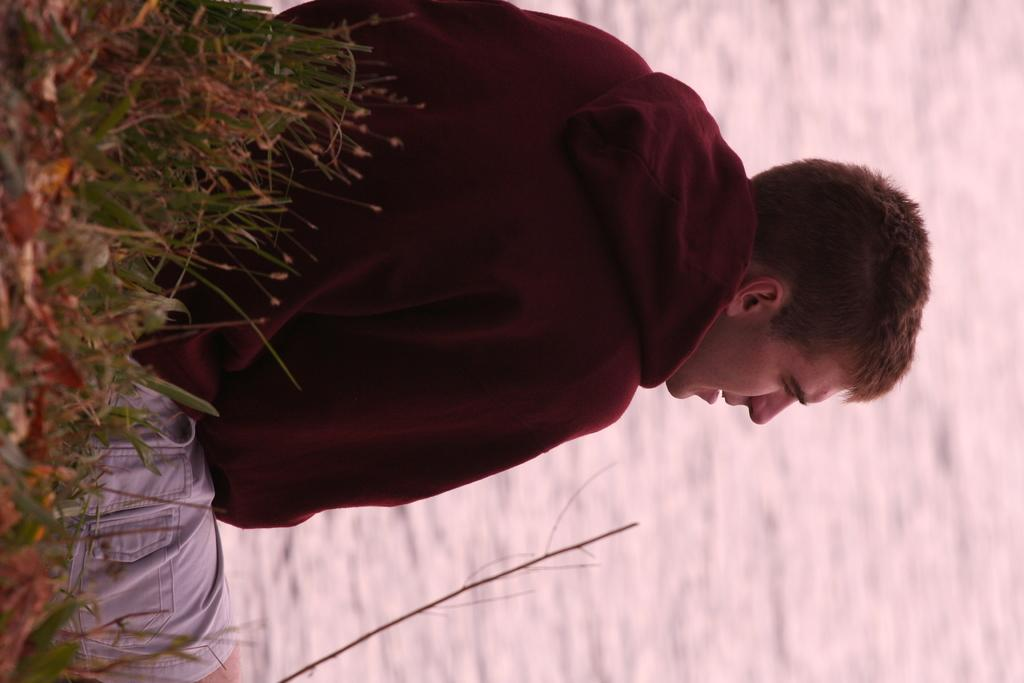What is the main subject in the center of the picture? There is a person sitting in the center of the picture. What type of vegetation is present on the left side of the image? There are shrubs and grass on the left side of the image. What can be seen on the right side of the image? There is a water body on the right side of the image. What color is the blood on the person's shirt in the image? There is no blood present on the person's shirt in the image. How many apples are visible in the image? There are no apples visible in the image. 